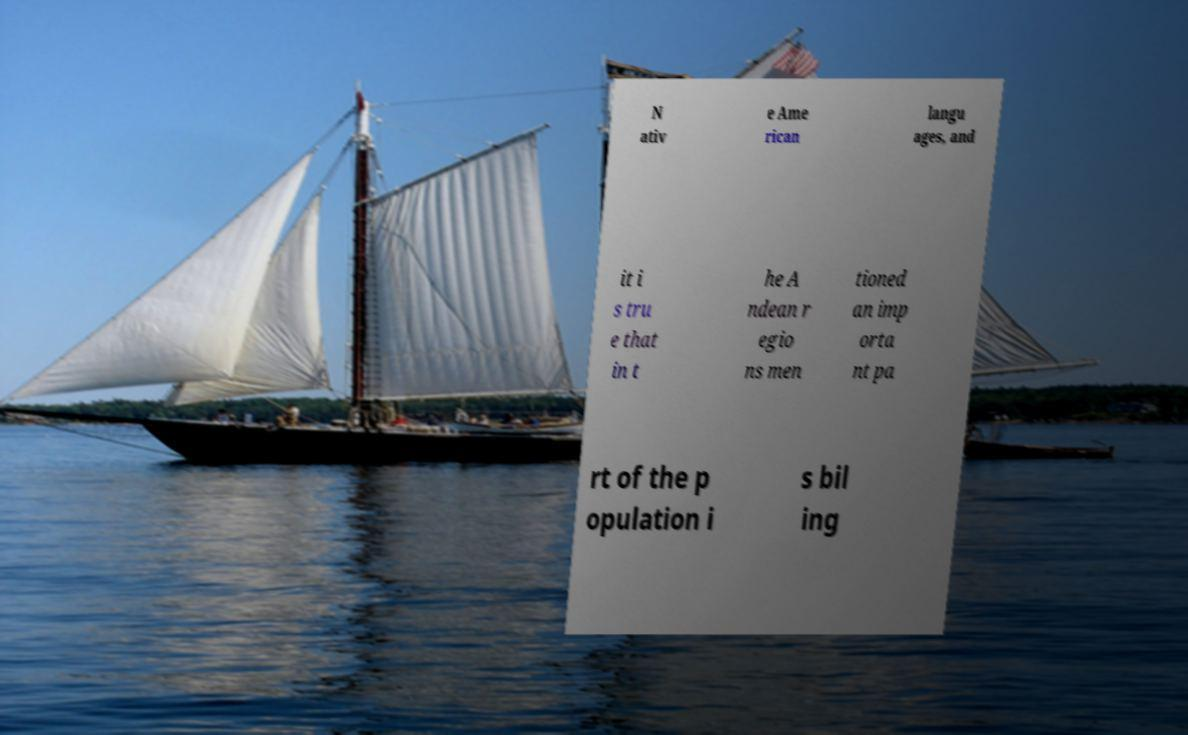Can you read and provide the text displayed in the image?This photo seems to have some interesting text. Can you extract and type it out for me? N ativ e Ame rican langu ages, and it i s tru e that in t he A ndean r egio ns men tioned an imp orta nt pa rt of the p opulation i s bil ing 